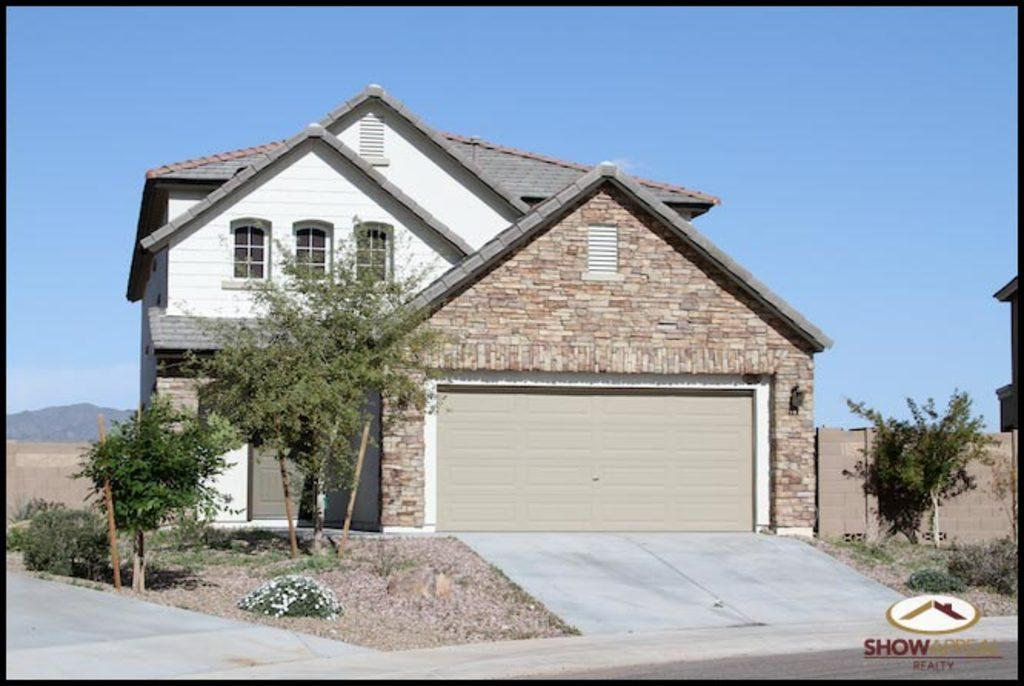What type of structure is present in the image? There is a house in the image. What natural elements can be seen in the image? There are trees, plants, and mountains visible in the image. What man-made feature is present in the image? There is a road in the image. What type of boundary is present in the image? There is a wooden boundary wall in the image. What is visible in the background of the image? The sky and mountains are visible in the background of the image. Can you tell me what the writer is doing in the image? There is no writer present in the image. How many snails can be seen crawling on the wooden boundary wall in the image? There are no snails visible in the image. 